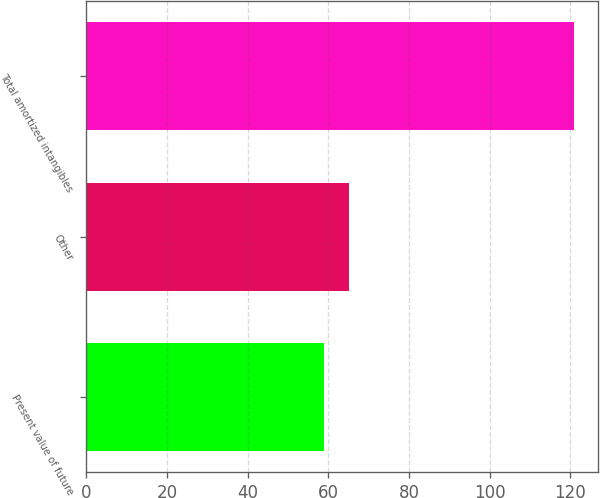Convert chart. <chart><loc_0><loc_0><loc_500><loc_500><bar_chart><fcel>Present value of future<fcel>Other<fcel>Total amortized intangibles<nl><fcel>58.9<fcel>65.09<fcel>120.8<nl></chart> 